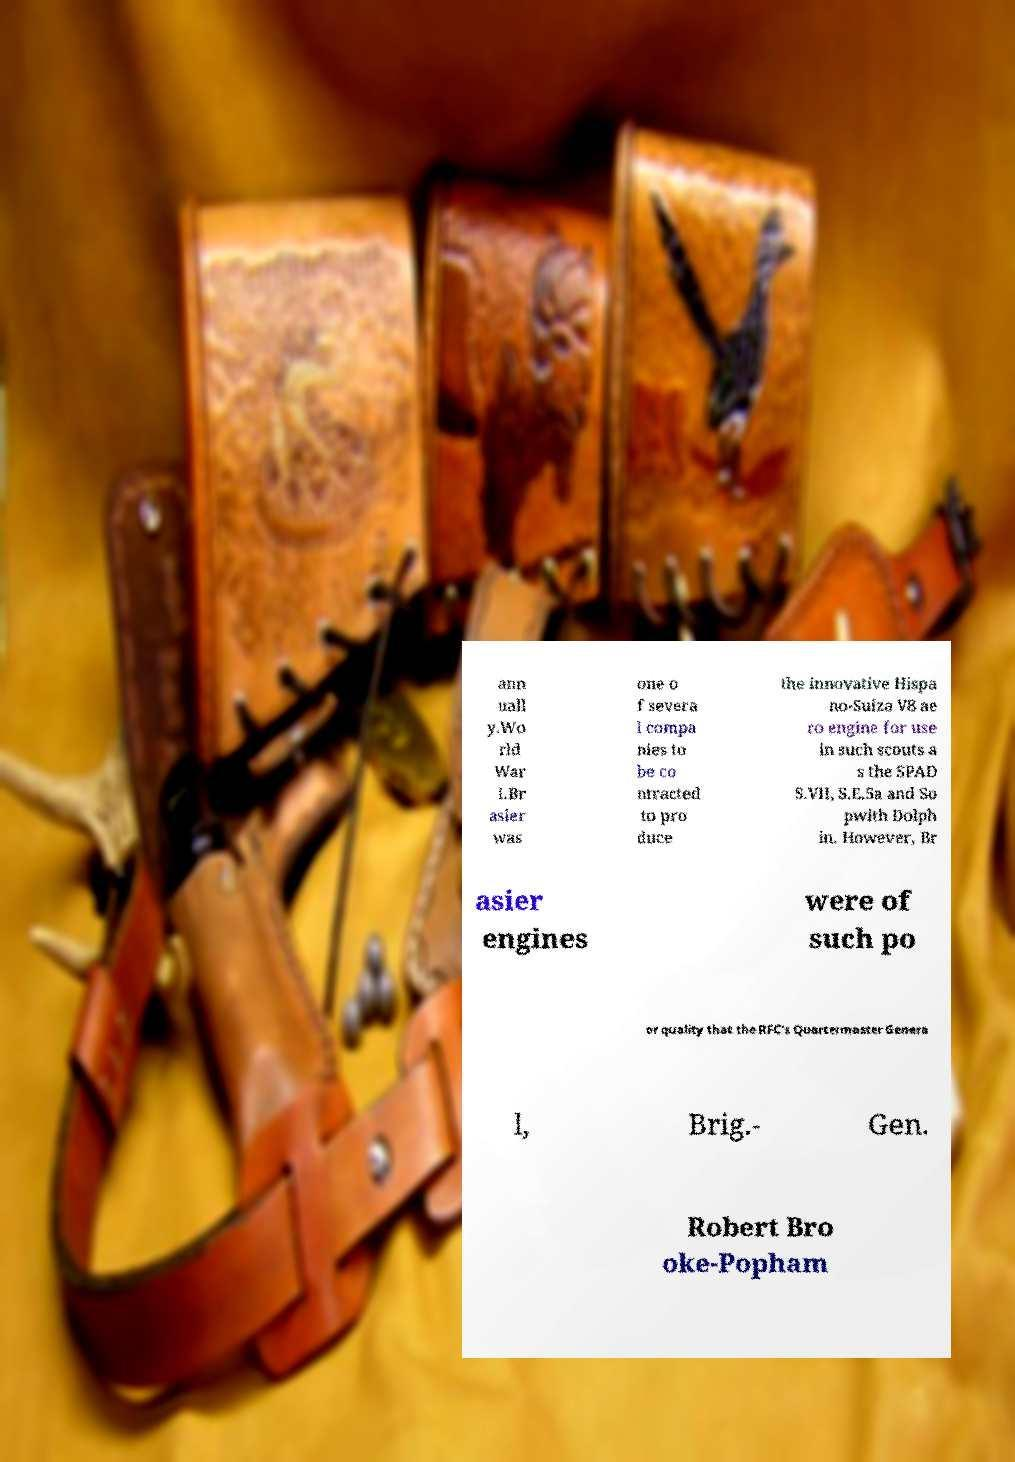What messages or text are displayed in this image? I need them in a readable, typed format. ann uall y.Wo rld War I.Br asier was one o f severa l compa nies to be co ntracted to pro duce the innovative Hispa no-Suiza V8 ae ro engine for use in such scouts a s the SPAD S.VII, S.E.5a and So pwith Dolph in. However, Br asier engines were of such po or quality that the RFC's Quartermaster Genera l, Brig.- Gen. Robert Bro oke-Popham 